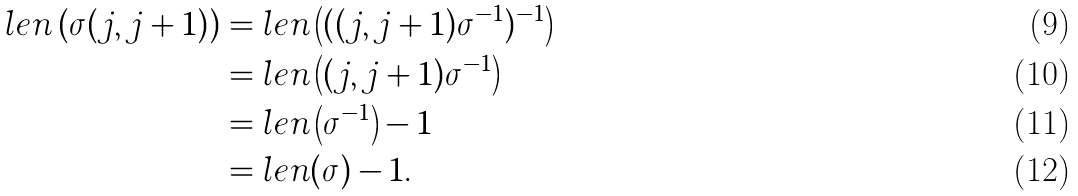<formula> <loc_0><loc_0><loc_500><loc_500>l e n \left ( \sigma ( j , j + 1 ) \right ) & = l e n \left ( ( ( j , j + 1 ) \sigma ^ { - 1 } ) ^ { - 1 } \right ) \\ & = l e n \left ( ( j , j + 1 ) \sigma ^ { - 1 } \right ) \\ & = l e n \left ( \sigma ^ { - 1 } \right ) - 1 \\ & = l e n ( \sigma ) - 1 .</formula> 